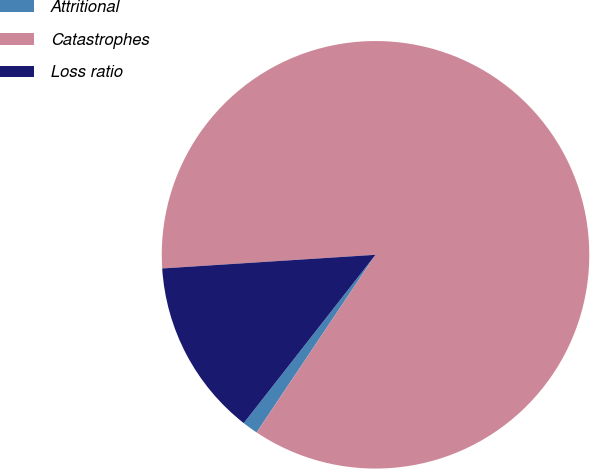Convert chart to OTSL. <chart><loc_0><loc_0><loc_500><loc_500><pie_chart><fcel>Attritional<fcel>Catastrophes<fcel>Loss ratio<nl><fcel>1.18%<fcel>85.4%<fcel>13.41%<nl></chart> 